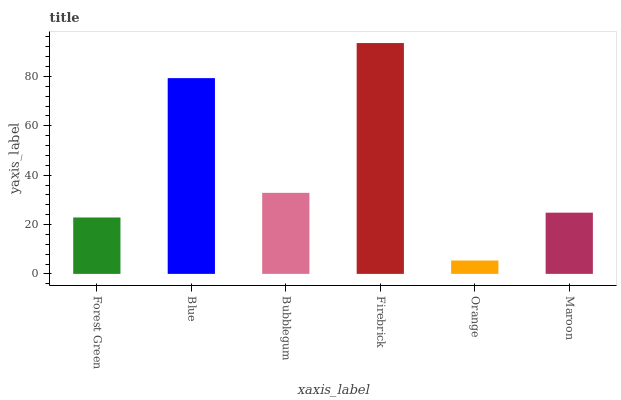Is Orange the minimum?
Answer yes or no. Yes. Is Firebrick the maximum?
Answer yes or no. Yes. Is Blue the minimum?
Answer yes or no. No. Is Blue the maximum?
Answer yes or no. No. Is Blue greater than Forest Green?
Answer yes or no. Yes. Is Forest Green less than Blue?
Answer yes or no. Yes. Is Forest Green greater than Blue?
Answer yes or no. No. Is Blue less than Forest Green?
Answer yes or no. No. Is Bubblegum the high median?
Answer yes or no. Yes. Is Maroon the low median?
Answer yes or no. Yes. Is Maroon the high median?
Answer yes or no. No. Is Blue the low median?
Answer yes or no. No. 